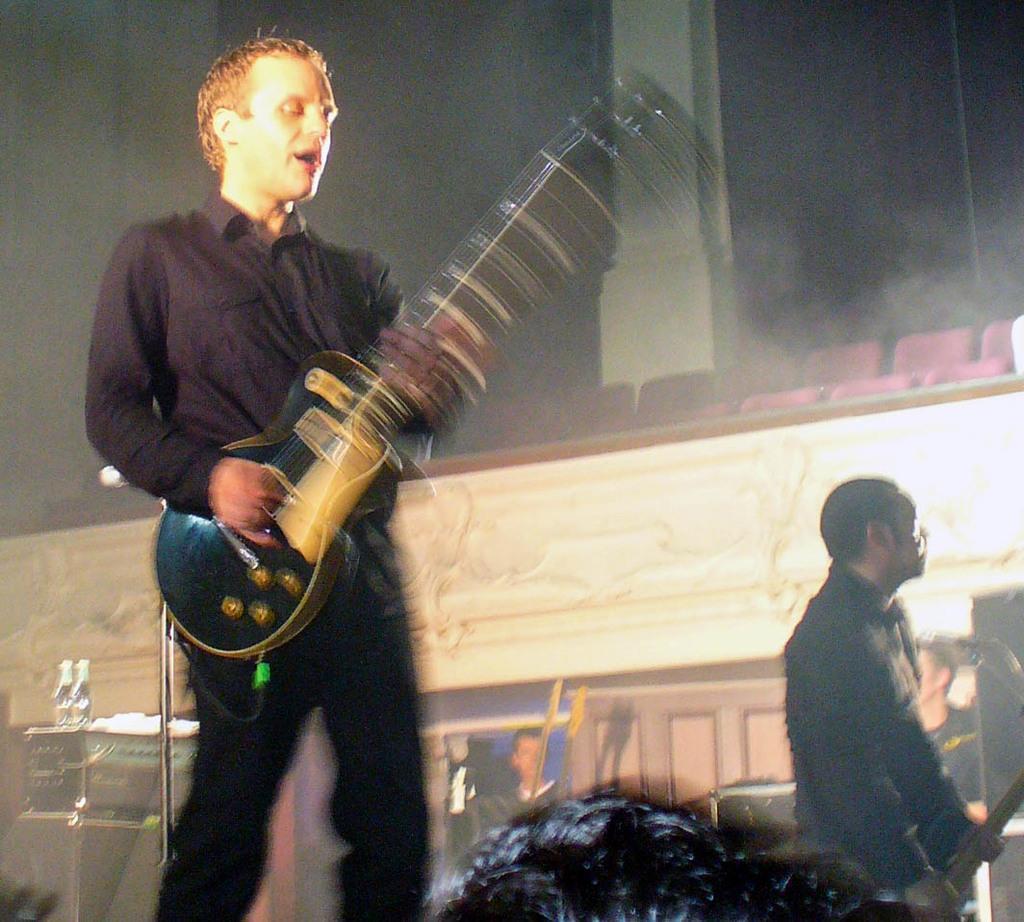How would you summarize this image in a sentence or two? In this picture there is a person who has singing, holding the guitar in his hands and playing it and there's another person who is has standing here, holding a object in his hand and the building in the background this also a wall. 